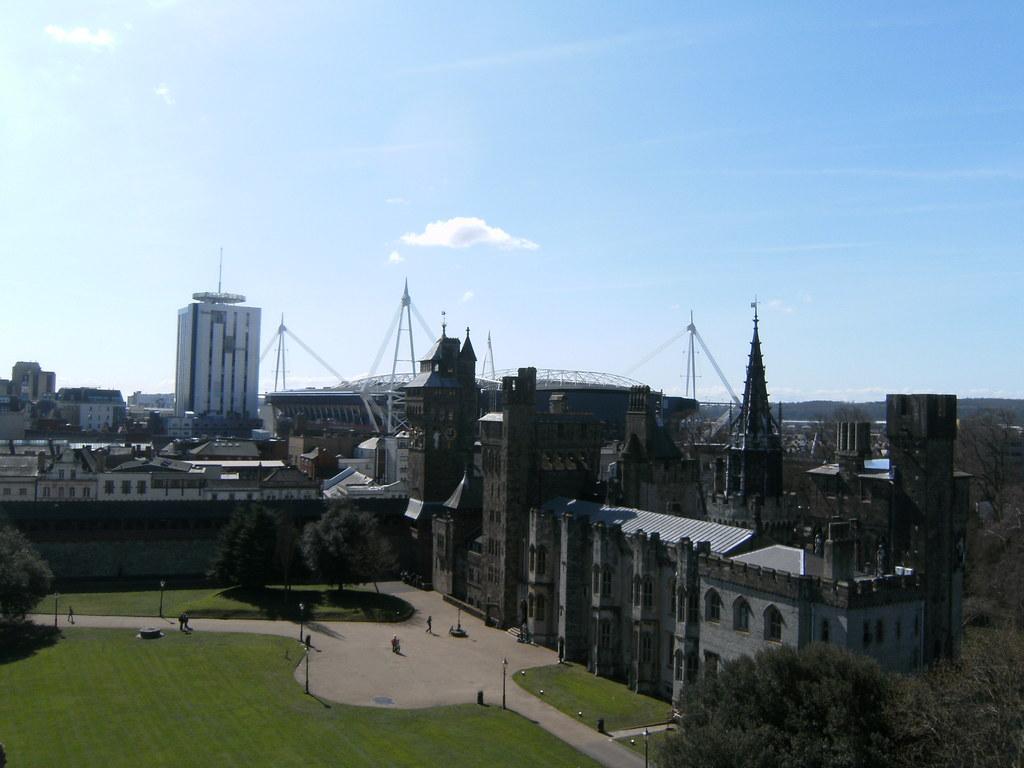Please provide a concise description of this image. This picture is clicked outside the city. At the bottom, we see the grass and poles. We even see the street lights. In the right bottom, we see the trees. In the middle, we see the trees. On the left side, we see a tree. There are trees, buildings and towers in the background. At the top, we see the sky and the clouds. 